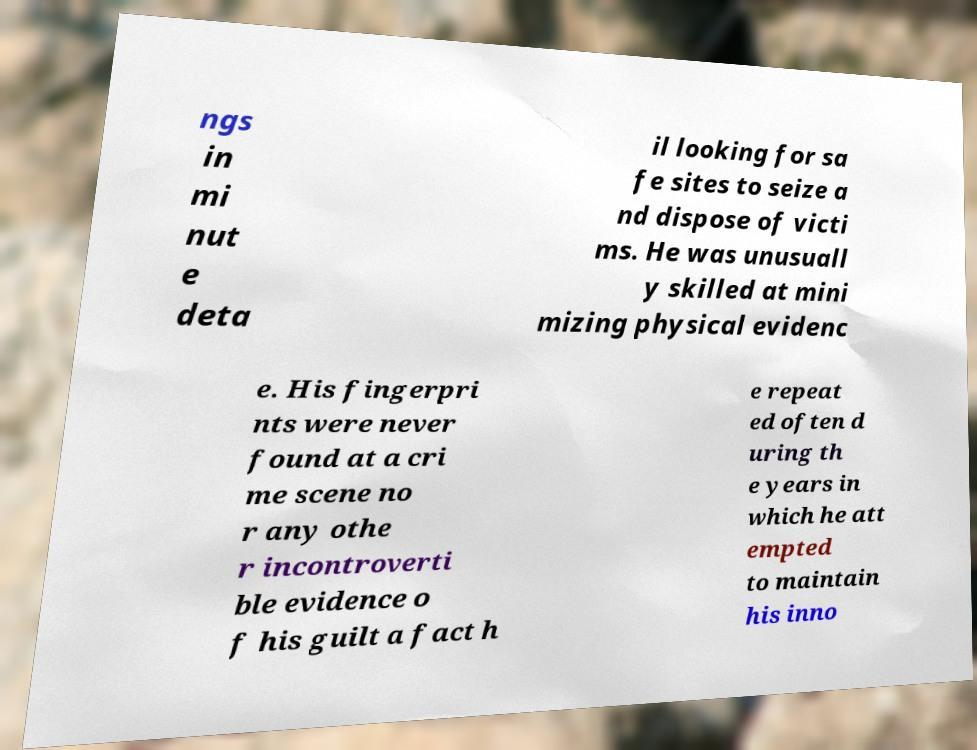Please read and relay the text visible in this image. What does it say? ngs in mi nut e deta il looking for sa fe sites to seize a nd dispose of victi ms. He was unusuall y skilled at mini mizing physical evidenc e. His fingerpri nts were never found at a cri me scene no r any othe r incontroverti ble evidence o f his guilt a fact h e repeat ed often d uring th e years in which he att empted to maintain his inno 